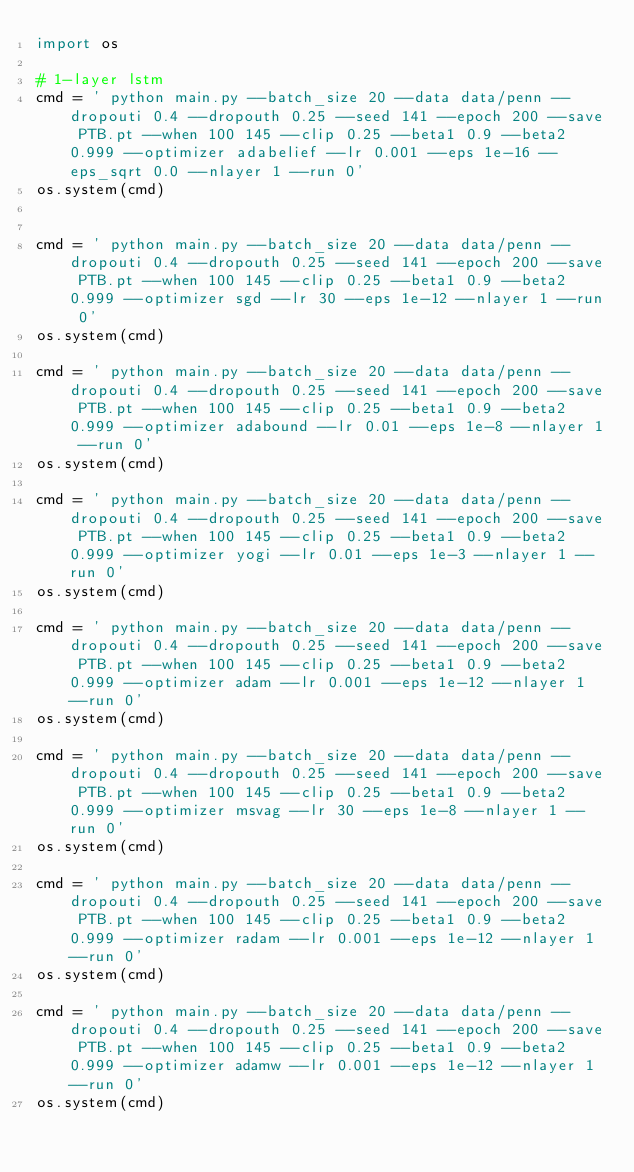Convert code to text. <code><loc_0><loc_0><loc_500><loc_500><_Python_>import os

# 1-layer lstm
cmd = ' python main.py --batch_size 20 --data data/penn --dropouti 0.4 --dropouth 0.25 --seed 141 --epoch 200 --save PTB.pt --when 100 145 --clip 0.25 --beta1 0.9 --beta2 0.999 --optimizer adabelief --lr 0.001 --eps 1e-16 --eps_sqrt 0.0 --nlayer 1 --run 0'
os.system(cmd)


cmd = ' python main.py --batch_size 20 --data data/penn --dropouti 0.4 --dropouth 0.25 --seed 141 --epoch 200 --save PTB.pt --when 100 145 --clip 0.25 --beta1 0.9 --beta2 0.999 --optimizer sgd --lr 30 --eps 1e-12 --nlayer 1 --run 0'
os.system(cmd)

cmd = ' python main.py --batch_size 20 --data data/penn --dropouti 0.4 --dropouth 0.25 --seed 141 --epoch 200 --save PTB.pt --when 100 145 --clip 0.25 --beta1 0.9 --beta2 0.999 --optimizer adabound --lr 0.01 --eps 1e-8 --nlayer 1 --run 0'
os.system(cmd)

cmd = ' python main.py --batch_size 20 --data data/penn --dropouti 0.4 --dropouth 0.25 --seed 141 --epoch 200 --save PTB.pt --when 100 145 --clip 0.25 --beta1 0.9 --beta2 0.999 --optimizer yogi --lr 0.01 --eps 1e-3 --nlayer 1 --run 0'
os.system(cmd)

cmd = ' python main.py --batch_size 20 --data data/penn --dropouti 0.4 --dropouth 0.25 --seed 141 --epoch 200 --save PTB.pt --when 100 145 --clip 0.25 --beta1 0.9 --beta2 0.999 --optimizer adam --lr 0.001 --eps 1e-12 --nlayer 1 --run 0'
os.system(cmd)

cmd = ' python main.py --batch_size 20 --data data/penn --dropouti 0.4 --dropouth 0.25 --seed 141 --epoch 200 --save PTB.pt --when 100 145 --clip 0.25 --beta1 0.9 --beta2 0.999 --optimizer msvag --lr 30 --eps 1e-8 --nlayer 1 --run 0'
os.system(cmd)

cmd = ' python main.py --batch_size 20 --data data/penn --dropouti 0.4 --dropouth 0.25 --seed 141 --epoch 200 --save PTB.pt --when 100 145 --clip 0.25 --beta1 0.9 --beta2 0.999 --optimizer radam --lr 0.001 --eps 1e-12 --nlayer 1 --run 0'
os.system(cmd)

cmd = ' python main.py --batch_size 20 --data data/penn --dropouti 0.4 --dropouth 0.25 --seed 141 --epoch 200 --save PTB.pt --when 100 145 --clip 0.25 --beta1 0.9 --beta2 0.999 --optimizer adamw --lr 0.001 --eps 1e-12 --nlayer 1 --run 0'
os.system(cmd)



</code> 